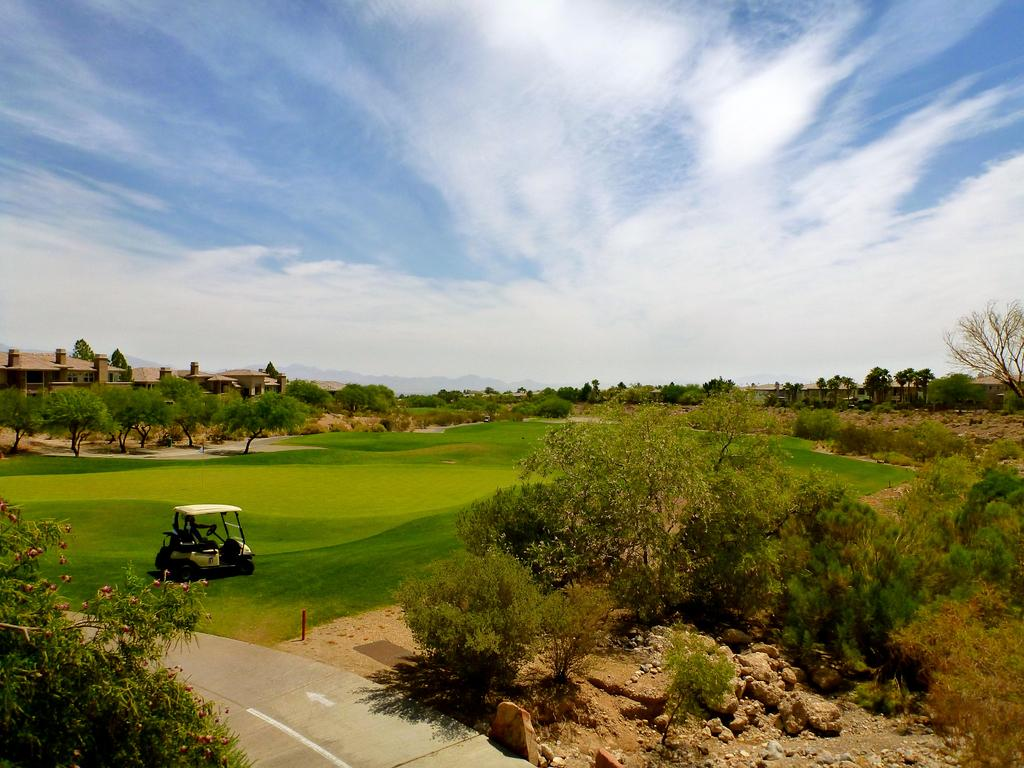What is the main subject of the image? There is a vehicle in the image. Where is the vehicle located? The vehicle is on a greenery ground. What can be seen around the vehicle? There are trees around the vehicle. What is visible in the background of the image? There are buildings in the background of the image. How many cubs are playing near the vehicle in the image? There are no cubs present in the image. What is the amount of snow visible in the image? There is no snow visible in the image; it is set in a greenery environment. 